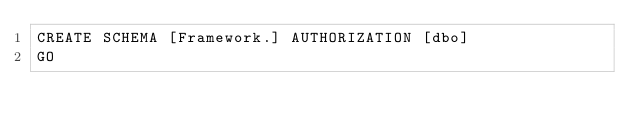<code> <loc_0><loc_0><loc_500><loc_500><_SQL_>CREATE SCHEMA [Framework.] AUTHORIZATION [dbo]
GO
</code> 